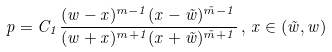<formula> <loc_0><loc_0><loc_500><loc_500>p = C _ { 1 } \frac { ( w - x ) ^ { m - 1 } ( x - \tilde { w } ) ^ { \tilde { m } - 1 } } { ( w + x ) ^ { m + 1 } ( x + \tilde { w } ) ^ { \tilde { m } + 1 } } \, , \, x \in ( \tilde { w } , w )</formula> 